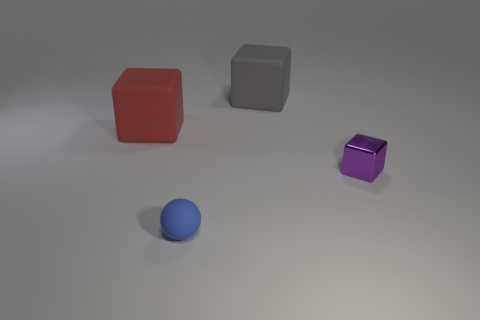Subtract all matte cubes. How many cubes are left? 1 Subtract all gray blocks. How many blocks are left? 2 Subtract all blocks. How many objects are left? 1 Subtract 1 balls. How many balls are left? 0 Subtract all red matte blocks. Subtract all big matte objects. How many objects are left? 1 Add 3 big matte things. How many big matte things are left? 5 Add 4 large red matte blocks. How many large red matte blocks exist? 5 Add 3 purple objects. How many objects exist? 7 Subtract 1 blue balls. How many objects are left? 3 Subtract all red cubes. Subtract all brown spheres. How many cubes are left? 2 